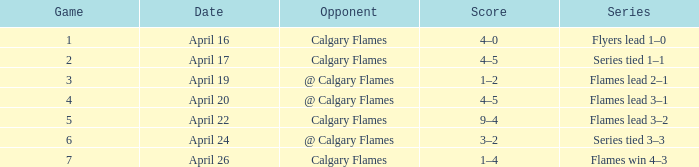Which series features an adversary of calgary flames, and a score of 9-4? Flames lead 3–2. 